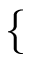Convert formula to latex. <formula><loc_0><loc_0><loc_500><loc_500>\{</formula> 